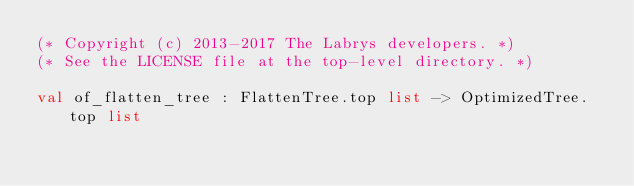<code> <loc_0><loc_0><loc_500><loc_500><_OCaml_>(* Copyright (c) 2013-2017 The Labrys developers. *)
(* See the LICENSE file at the top-level directory. *)

val of_flatten_tree : FlattenTree.top list -> OptimizedTree.top list
</code> 